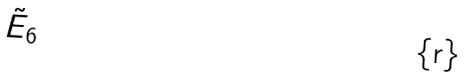Convert formula to latex. <formula><loc_0><loc_0><loc_500><loc_500>\tilde { E } _ { 6 }</formula> 